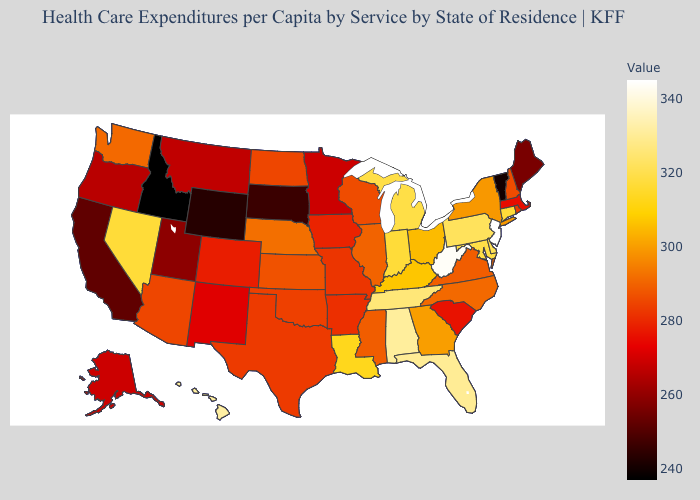Among the states that border Missouri , which have the highest value?
Answer briefly. Tennessee. Does the map have missing data?
Be succinct. No. Does Delaware have the lowest value in the USA?
Short answer required. No. Does New Jersey have the highest value in the USA?
Concise answer only. Yes. Does the map have missing data?
Concise answer only. No. Does Ohio have the lowest value in the MidWest?
Keep it brief. No. Which states have the lowest value in the USA?
Keep it brief. Idaho. 